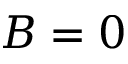<formula> <loc_0><loc_0><loc_500><loc_500>B = 0</formula> 